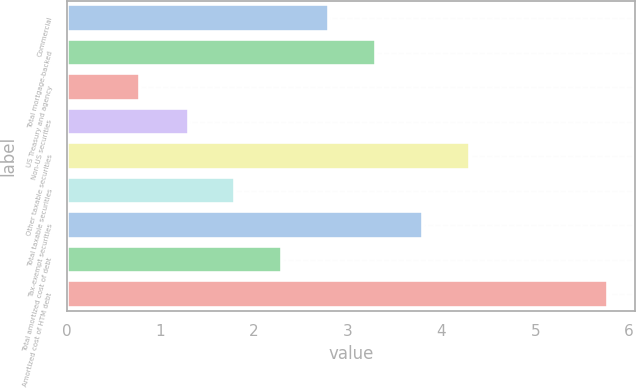<chart> <loc_0><loc_0><loc_500><loc_500><bar_chart><fcel>Commercial<fcel>Total mortgage-backed<fcel>US Treasury and agency<fcel>Non-US securities<fcel>Other taxable securities<fcel>Total taxable securities<fcel>Tax-exempt securities<fcel>Total amortized cost of debt<fcel>Amortized cost of HTM debt<nl><fcel>2.8<fcel>3.3<fcel>0.78<fcel>1.3<fcel>4.3<fcel>1.8<fcel>3.8<fcel>2.3<fcel>5.78<nl></chart> 